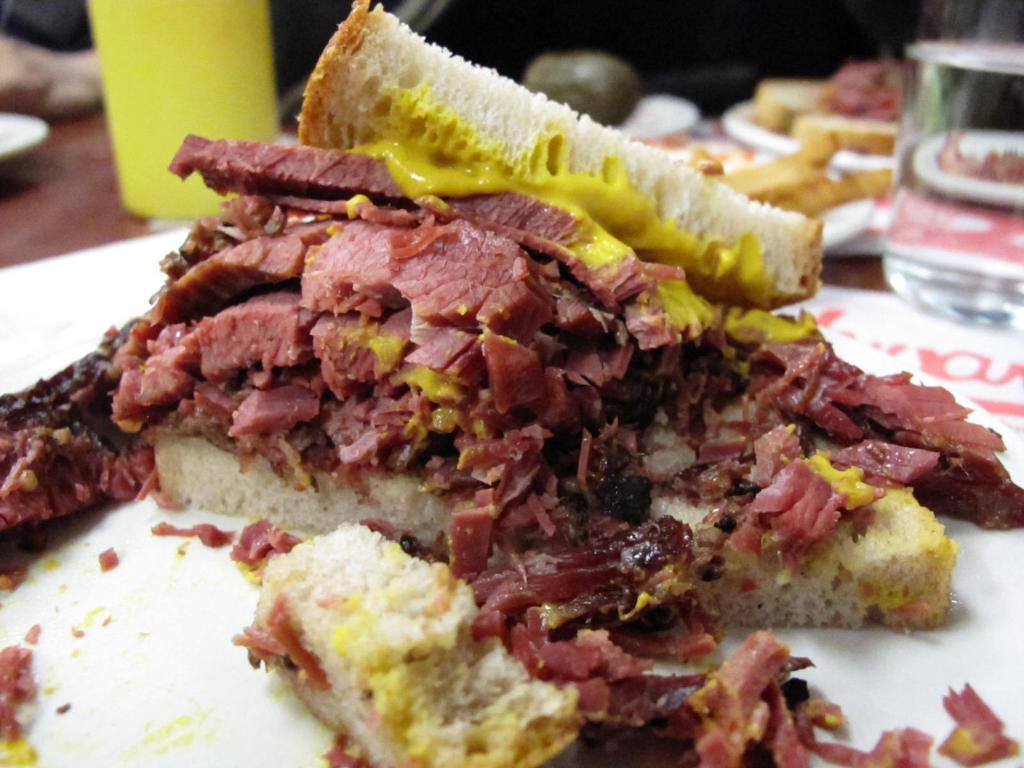How would you summarize this image in a sentence or two? On this white plate there is a food. Here we can see glasses. 